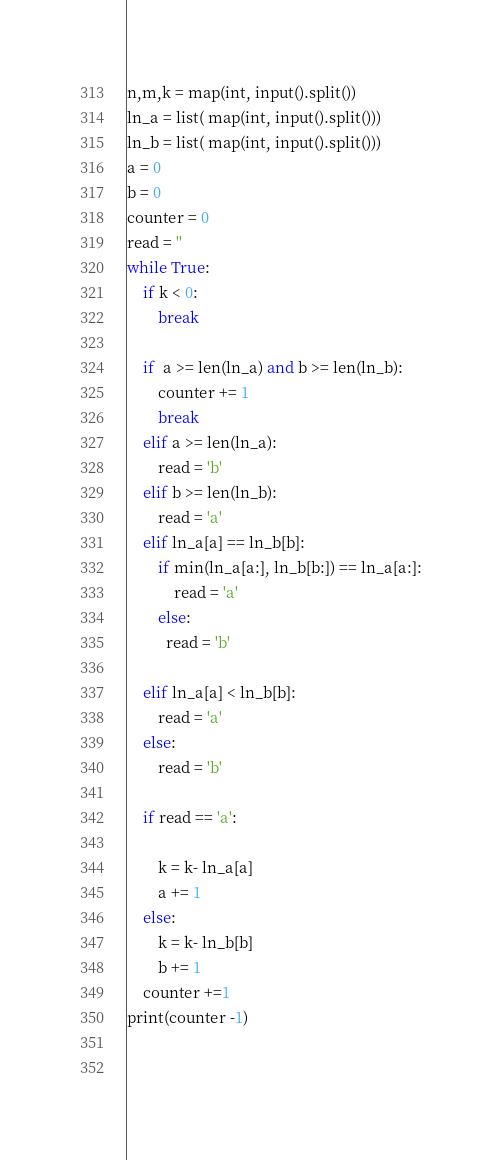<code> <loc_0><loc_0><loc_500><loc_500><_Python_>n,m,k = map(int, input().split())
ln_a = list( map(int, input().split()))
ln_b = list( map(int, input().split()))
a = 0
b = 0
counter = 0
read = ''
while True:
    if k < 0:
        break
        
    if  a >= len(ln_a) and b >= len(ln_b):
        counter += 1
        break
    elif a >= len(ln_a):
        read = 'b'
    elif b >= len(ln_b):
        read = 'a'
    elif ln_a[a] == ln_b[b]:
        if min(ln_a[a:], ln_b[b:]) == ln_a[a:]:
            read = 'a'
        else:
          read = 'b'
        
    elif ln_a[a] < ln_b[b]:
        read = 'a'
    else:
        read = 'b'
    
    if read == 'a':
        
        k = k- ln_a[a]
        a += 1
    else:
        k = k- ln_b[b]
        b += 1
    counter +=1
print(counter -1)
        
        </code> 